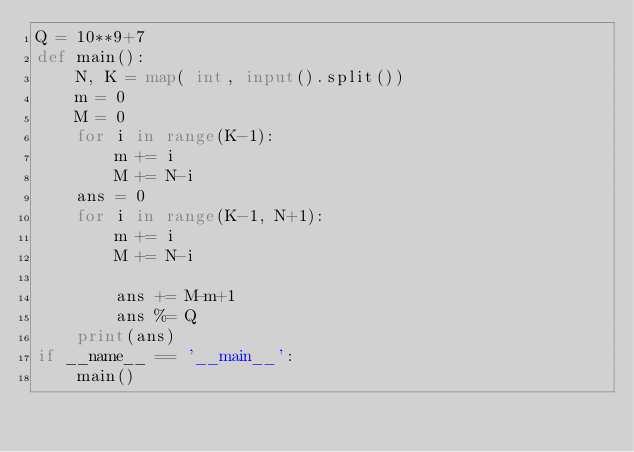Convert code to text. <code><loc_0><loc_0><loc_500><loc_500><_Python_>Q = 10**9+7
def main():
    N, K = map( int, input().split())
    m = 0
    M = 0
    for i in range(K-1):
        m += i
        M += N-i
    ans = 0
    for i in range(K-1, N+1):
        m += i
        M += N-i

        ans += M-m+1
        ans %= Q
    print(ans)
if __name__ == '__main__':
    main()
</code> 